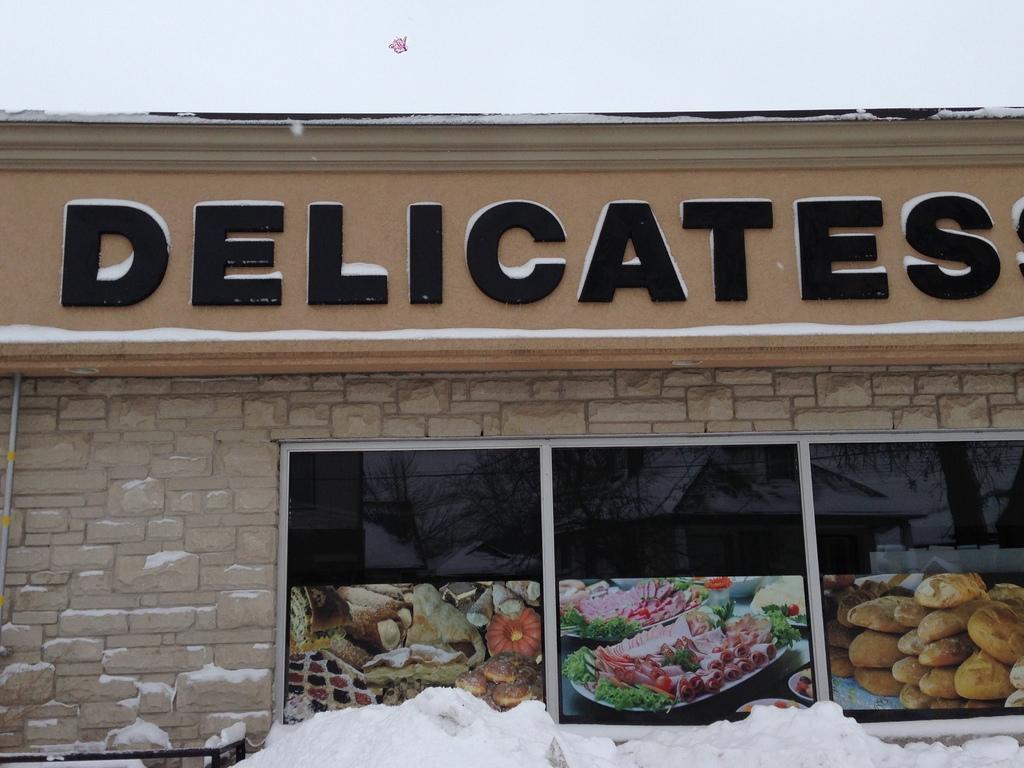Describe this image in one or two sentences. In this picture I can see there is a building and there is a nameplate and it has pictures of food and there is snow here on the floor. 